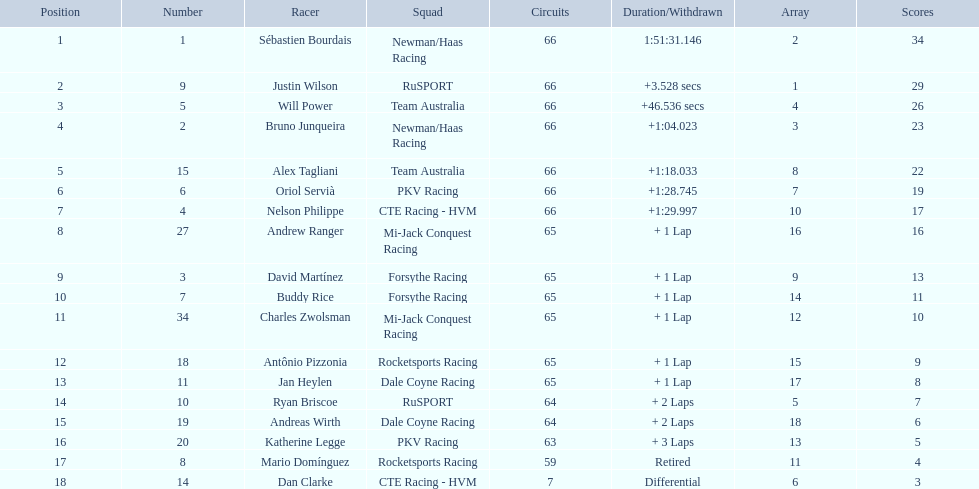Who are all the drivers? Sébastien Bourdais, Justin Wilson, Will Power, Bruno Junqueira, Alex Tagliani, Oriol Servià, Nelson Philippe, Andrew Ranger, David Martínez, Buddy Rice, Charles Zwolsman, Antônio Pizzonia, Jan Heylen, Ryan Briscoe, Andreas Wirth, Katherine Legge, Mario Domínguez, Dan Clarke. What position did they reach? 1, 2, 3, 4, 5, 6, 7, 8, 9, 10, 11, 12, 13, 14, 15, 16, 17, 18. What is the number for each driver? 1, 9, 5, 2, 15, 6, 4, 27, 3, 7, 34, 18, 11, 10, 19, 20, 8, 14. And which player's number and position match? Sébastien Bourdais. 